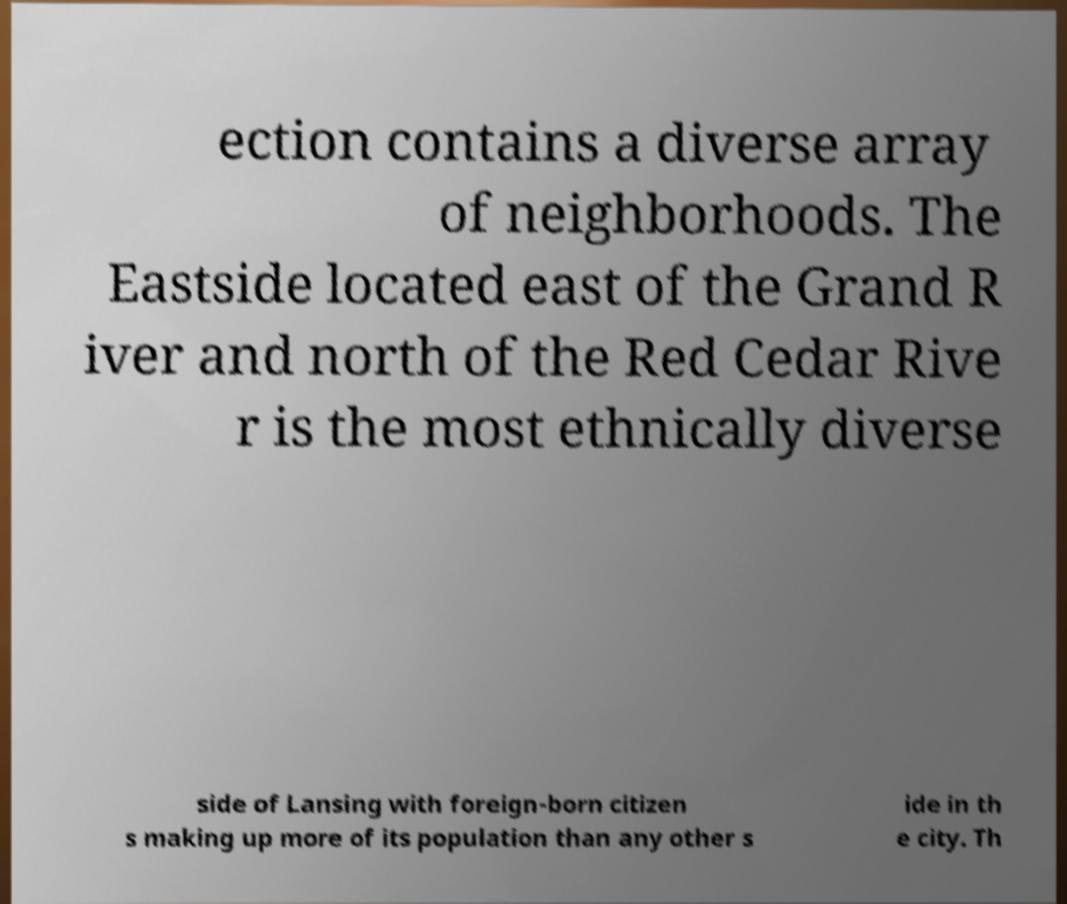Please read and relay the text visible in this image. What does it say? ection contains a diverse array of neighborhoods. The Eastside located east of the Grand R iver and north of the Red Cedar Rive r is the most ethnically diverse side of Lansing with foreign-born citizen s making up more of its population than any other s ide in th e city. Th 